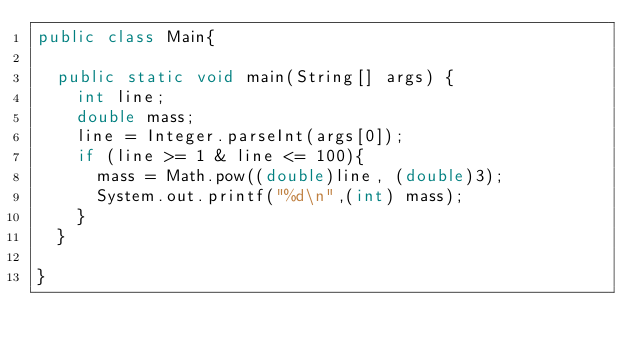<code> <loc_0><loc_0><loc_500><loc_500><_Java_>public class Main{

	public static void main(String[] args) {
		int line;
		double mass;
		line = Integer.parseInt(args[0]);
		if (line >= 1 & line <= 100){
			mass = Math.pow((double)line, (double)3);
			System.out.printf("%d\n",(int) mass);
		}
	}

}

</code> 